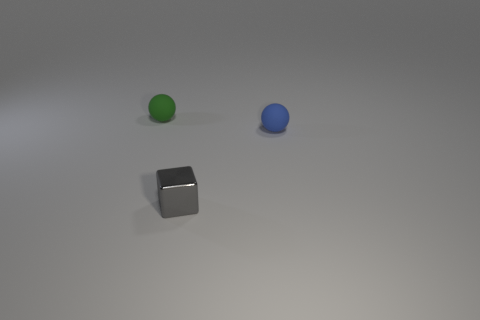Add 3 small spheres. How many objects exist? 6 Subtract all blue balls. How many balls are left? 1 Subtract 0 blue cylinders. How many objects are left? 3 Subtract all balls. How many objects are left? 1 Subtract 1 spheres. How many spheres are left? 1 Subtract all brown spheres. Subtract all blue cylinders. How many spheres are left? 2 Subtract all yellow cylinders. How many blue cubes are left? 0 Subtract all green spheres. Subtract all blue things. How many objects are left? 1 Add 2 gray blocks. How many gray blocks are left? 3 Add 2 metal blocks. How many metal blocks exist? 3 